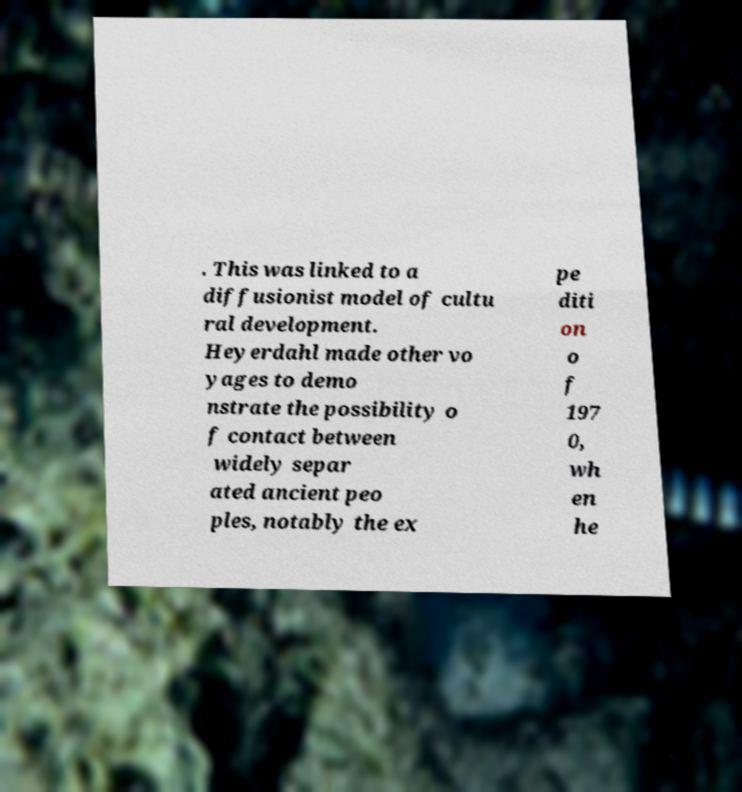There's text embedded in this image that I need extracted. Can you transcribe it verbatim? . This was linked to a diffusionist model of cultu ral development. Heyerdahl made other vo yages to demo nstrate the possibility o f contact between widely separ ated ancient peo ples, notably the ex pe diti on o f 197 0, wh en he 